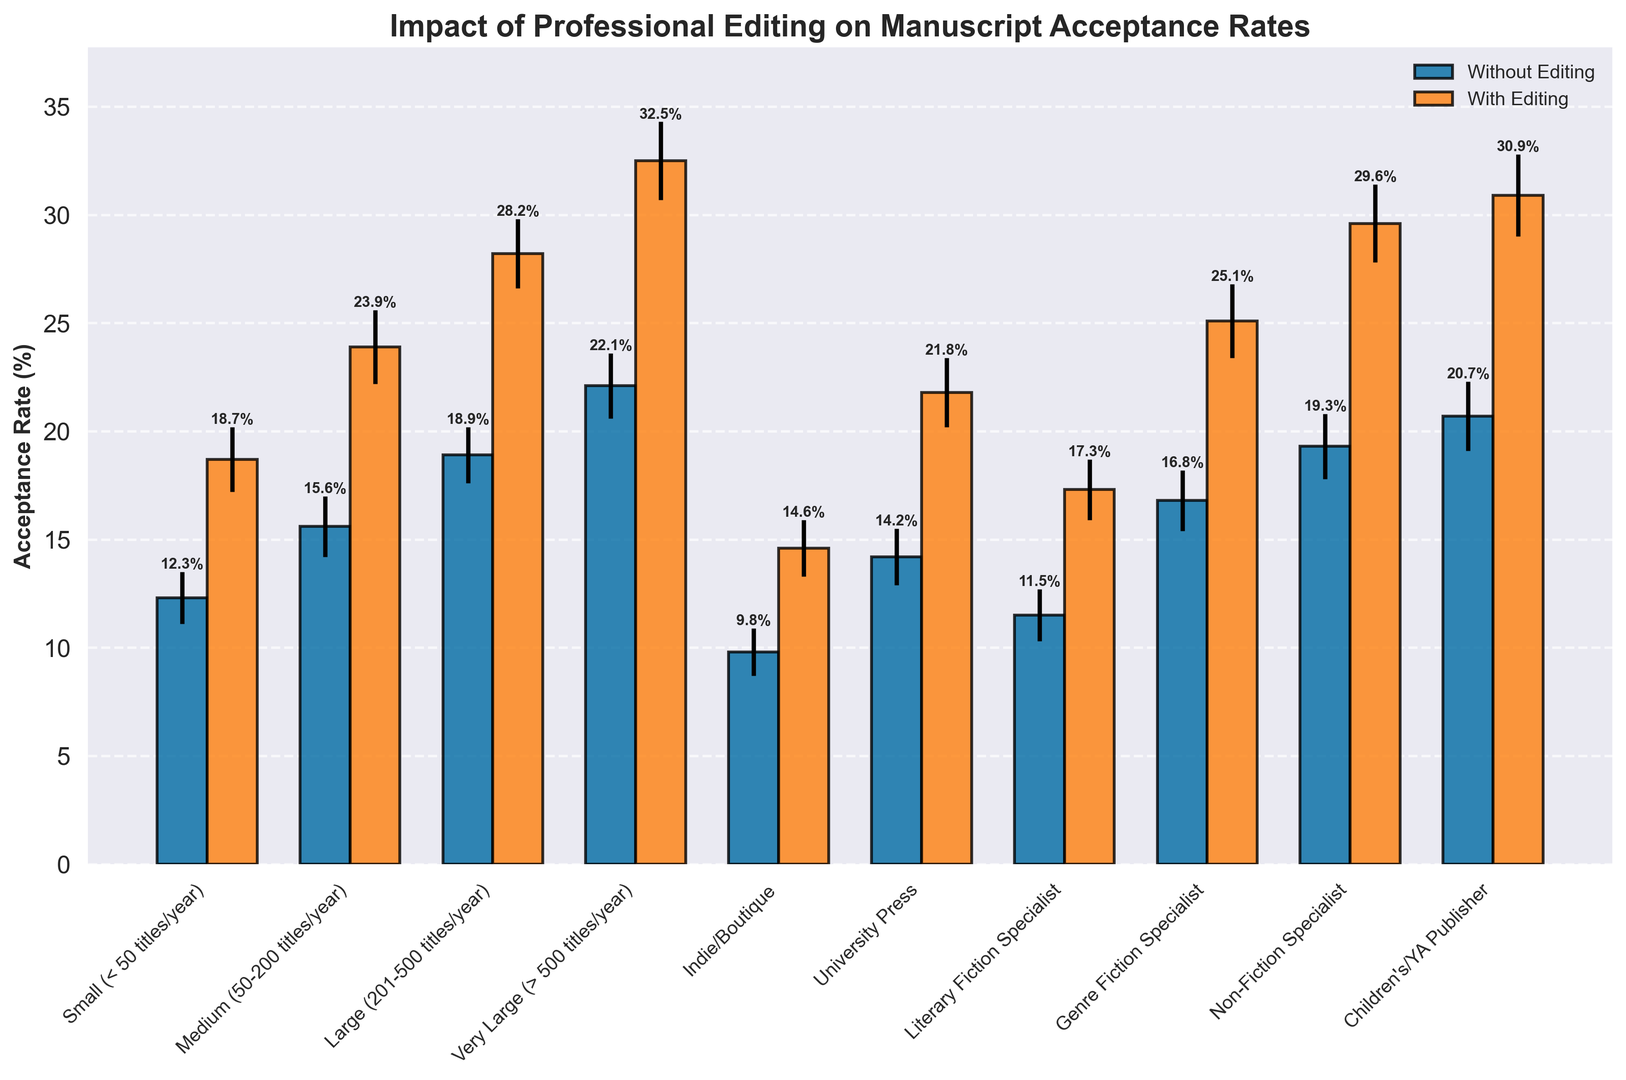What is the acceptance rate without editing for Large publishers? Look for the bar representing Large publishers without editing and read the value.
Answer: 18.9% Which publisher size has the highest acceptance rate with editing? Identify the tallest bar representing acceptance rates with editing and read the corresponding publisher size.
Answer: Very Large (> 500 titles/year) How much greater is the acceptance rate with editing than without editing for Indie/Boutique publishers? Subtract the acceptance rate without editing from the acceptance rate with editing for Indie/Boutique publishers.
Answer: 4.8% What is the average acceptance rate without editing across all publisher sizes? Add all acceptance rates without editing and divide by the number of publisher sizes (10).
Answer: 16.12% Compare the acceptance rate without editing between Medium and Non-Fiction Specialist publishers. Which is higher? Look at the bars for Medium and Non-Fiction Specialist publishers without editing and compare their values.
Answer: Non-Fiction Specialist Which publisher size shows the smallest increase in acceptance rate due to editing? Calculate the difference between acceptance rates with and without editing for each publisher size and identify the smallest increase.
Answer: Indie/Boutique For Children's/YA Publisher, what is the combined error bar value for acceptance rates with and without editing? Add the error values for with and without editing for Children's/YA Publisher.
Answer: 3.5 Is the acceptance rate with editing for University Press higher than the acceptance rate without editing for Very Large publishers? Compare the acceptance rate with editing for University Press with the acceptance rate without editing for Very Large publishers.
Answer: No 